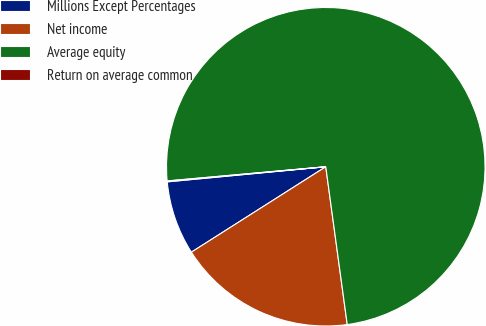Convert chart to OTSL. <chart><loc_0><loc_0><loc_500><loc_500><pie_chart><fcel>Millions Except Percentages<fcel>Net income<fcel>Average equity<fcel>Return on average common<nl><fcel>7.5%<fcel>18.14%<fcel>74.27%<fcel>0.09%<nl></chart> 